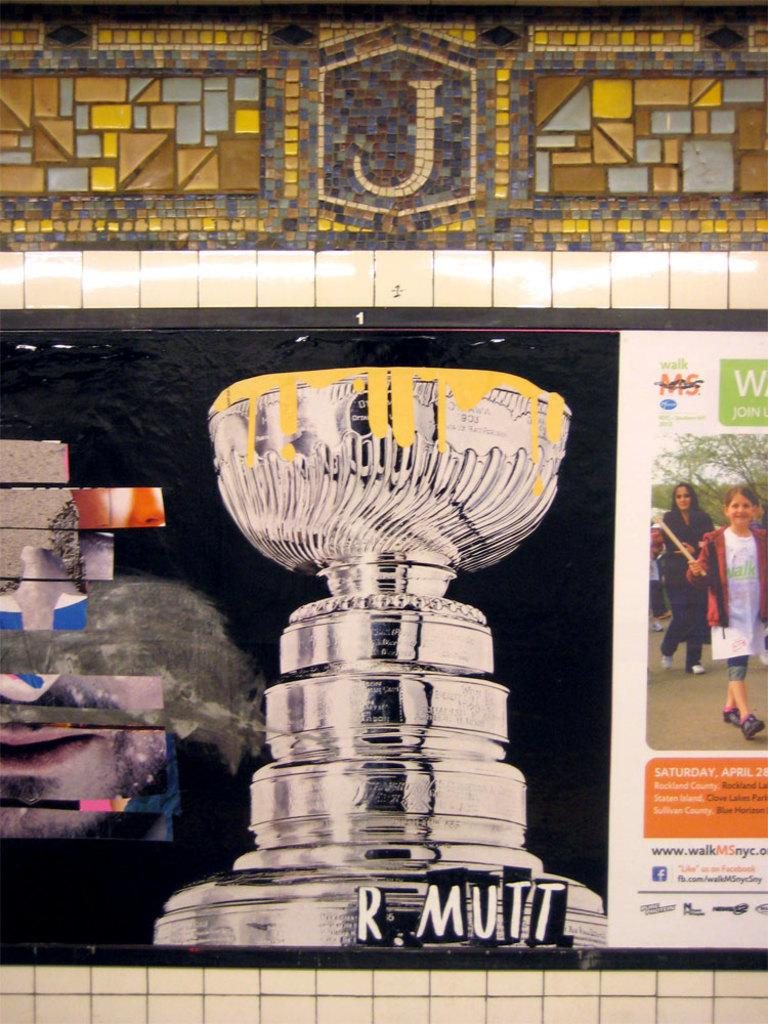What is the main subject of the painting in the image? The main subject of the painting in the image is a trophy. What else can be seen on the wall in the image? There are pictures of people and text on the wall in the image. How many kittens are sitting on the trophy in the image? There are no kittens present in the image, and the trophy is not depicted as having any kittens on it. 